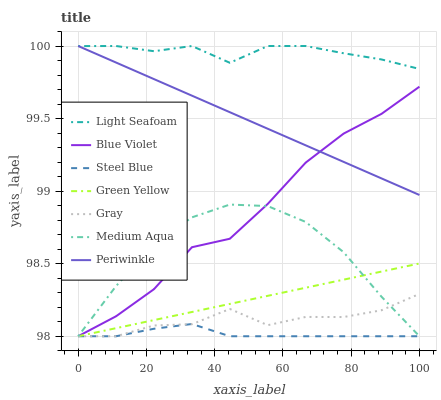Does Steel Blue have the minimum area under the curve?
Answer yes or no. Yes. Does Light Seafoam have the maximum area under the curve?
Answer yes or no. Yes. Does Light Seafoam have the minimum area under the curve?
Answer yes or no. No. Does Steel Blue have the maximum area under the curve?
Answer yes or no. No. Is Periwinkle the smoothest?
Answer yes or no. Yes. Is Blue Violet the roughest?
Answer yes or no. Yes. Is Light Seafoam the smoothest?
Answer yes or no. No. Is Light Seafoam the roughest?
Answer yes or no. No. Does Gray have the lowest value?
Answer yes or no. Yes. Does Light Seafoam have the lowest value?
Answer yes or no. No. Does Periwinkle have the highest value?
Answer yes or no. Yes. Does Steel Blue have the highest value?
Answer yes or no. No. Is Medium Aqua less than Periwinkle?
Answer yes or no. Yes. Is Periwinkle greater than Steel Blue?
Answer yes or no. Yes. Does Blue Violet intersect Green Yellow?
Answer yes or no. Yes. Is Blue Violet less than Green Yellow?
Answer yes or no. No. Is Blue Violet greater than Green Yellow?
Answer yes or no. No. Does Medium Aqua intersect Periwinkle?
Answer yes or no. No. 